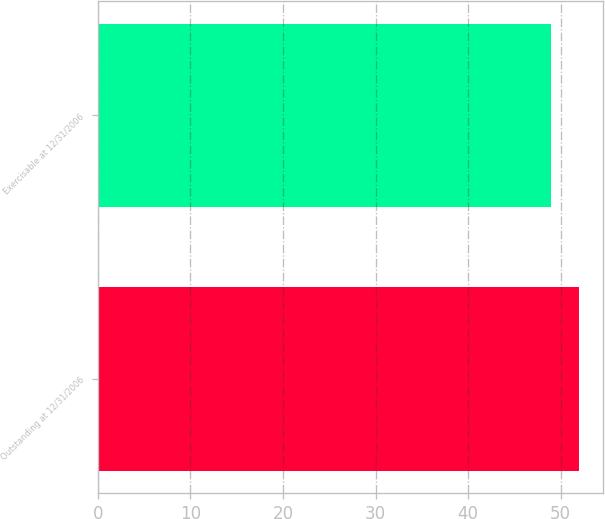Convert chart. <chart><loc_0><loc_0><loc_500><loc_500><bar_chart><fcel>Outstanding at 12/31/2006<fcel>Exercisable at 12/31/2006<nl><fcel>52<fcel>49<nl></chart> 